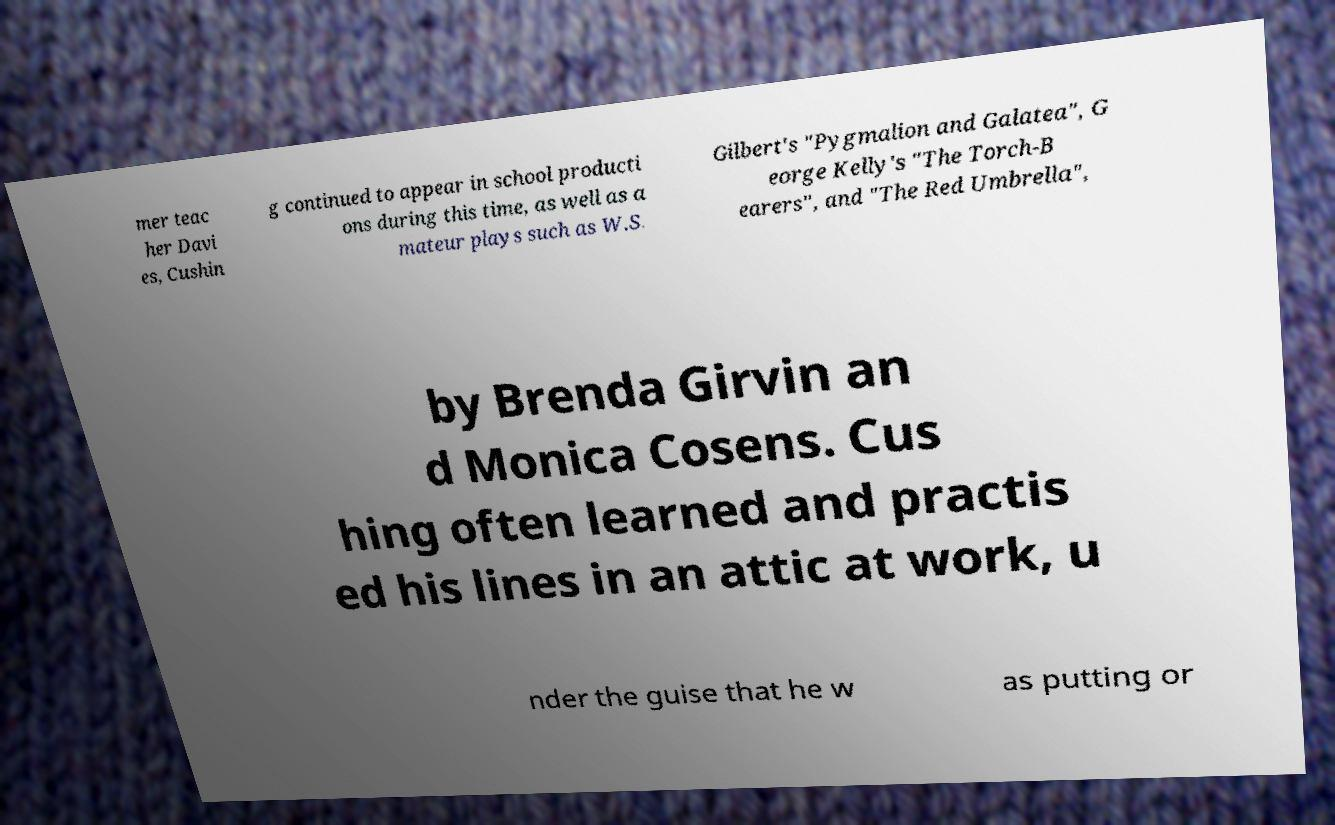There's text embedded in this image that I need extracted. Can you transcribe it verbatim? mer teac her Davi es, Cushin g continued to appear in school producti ons during this time, as well as a mateur plays such as W.S. Gilbert's "Pygmalion and Galatea", G eorge Kelly's "The Torch-B earers", and "The Red Umbrella", by Brenda Girvin an d Monica Cosens. Cus hing often learned and practis ed his lines in an attic at work, u nder the guise that he w as putting or 